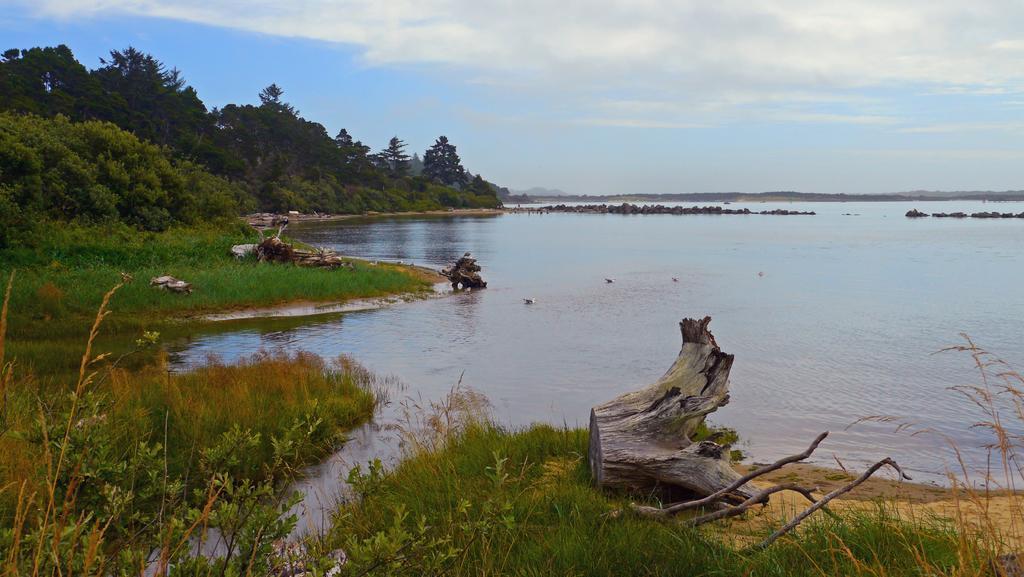Could you give a brief overview of what you see in this image? In this image I can see tree trunks, grass, water, trees and the sky. This image is taken may be near the lake. 